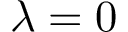<formula> <loc_0><loc_0><loc_500><loc_500>{ \lambda = 0 }</formula> 